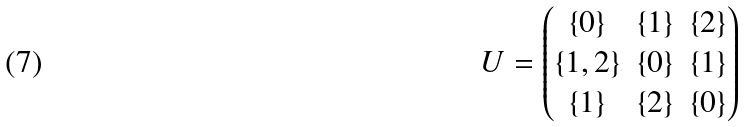<formula> <loc_0><loc_0><loc_500><loc_500>U = \begin{pmatrix} \{ 0 \} & \{ 1 \} & \{ 2 \} \\ \{ 1 , 2 \} & \{ 0 \} & \{ 1 \} \\ \{ 1 \} & \{ 2 \} & \{ 0 \} \end{pmatrix}</formula> 